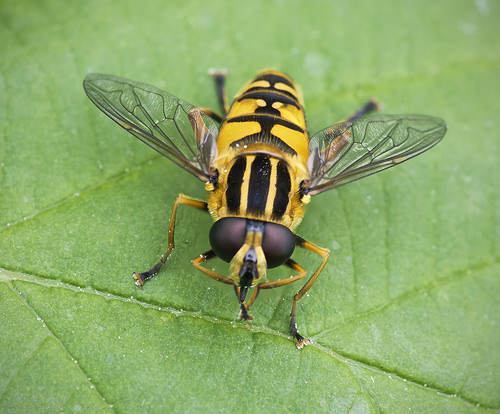<image>
Is there a bug on the leaf? Yes. Looking at the image, I can see the bug is positioned on top of the leaf, with the leaf providing support. 